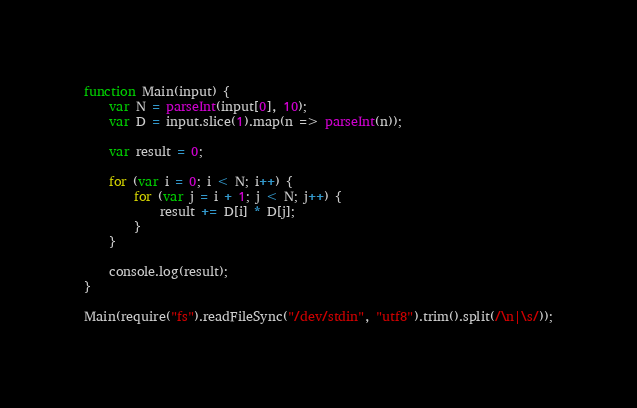Convert code to text. <code><loc_0><loc_0><loc_500><loc_500><_JavaScript_>function Main(input) {
    var N = parseInt(input[0], 10);
    var D = input.slice(1).map(n => parseInt(n));

    var result = 0;

    for (var i = 0; i < N; i++) {
        for (var j = i + 1; j < N; j++) {
            result += D[i] * D[j];
        }
    }

    console.log(result);
}

Main(require("fs").readFileSync("/dev/stdin", "utf8").trim().split(/\n|\s/));</code> 